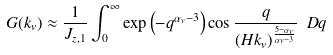<formula> <loc_0><loc_0><loc_500><loc_500>G ( k _ { v } ) \approx \frac { 1 } { J _ { z , 1 } } \int _ { 0 } ^ { \infty } \exp \left ( - q ^ { \alpha _ { v } - 3 } \right ) \cos \frac { q } { ( H k _ { v } ) ^ { \frac { 5 - \alpha _ { v } } { \alpha _ { v } - 3 } } } \ D { q }</formula> 